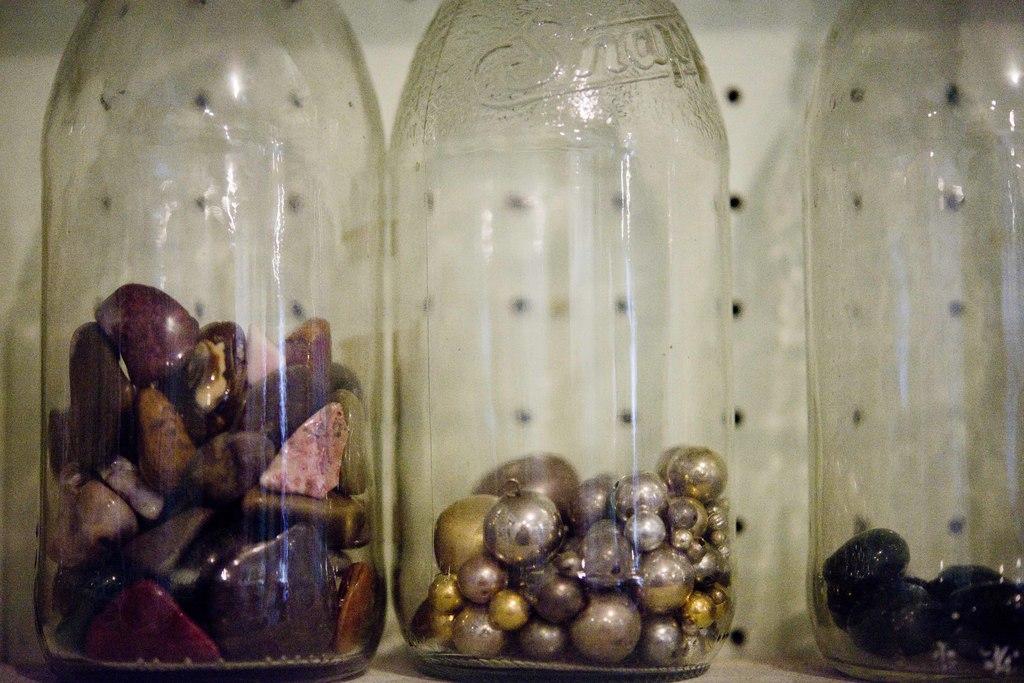What brand of bottle is it?
Offer a very short reply. Snapple. 